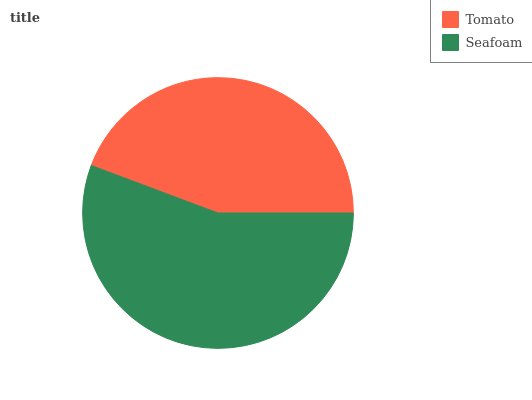Is Tomato the minimum?
Answer yes or no. Yes. Is Seafoam the maximum?
Answer yes or no. Yes. Is Seafoam the minimum?
Answer yes or no. No. Is Seafoam greater than Tomato?
Answer yes or no. Yes. Is Tomato less than Seafoam?
Answer yes or no. Yes. Is Tomato greater than Seafoam?
Answer yes or no. No. Is Seafoam less than Tomato?
Answer yes or no. No. Is Seafoam the high median?
Answer yes or no. Yes. Is Tomato the low median?
Answer yes or no. Yes. Is Tomato the high median?
Answer yes or no. No. Is Seafoam the low median?
Answer yes or no. No. 